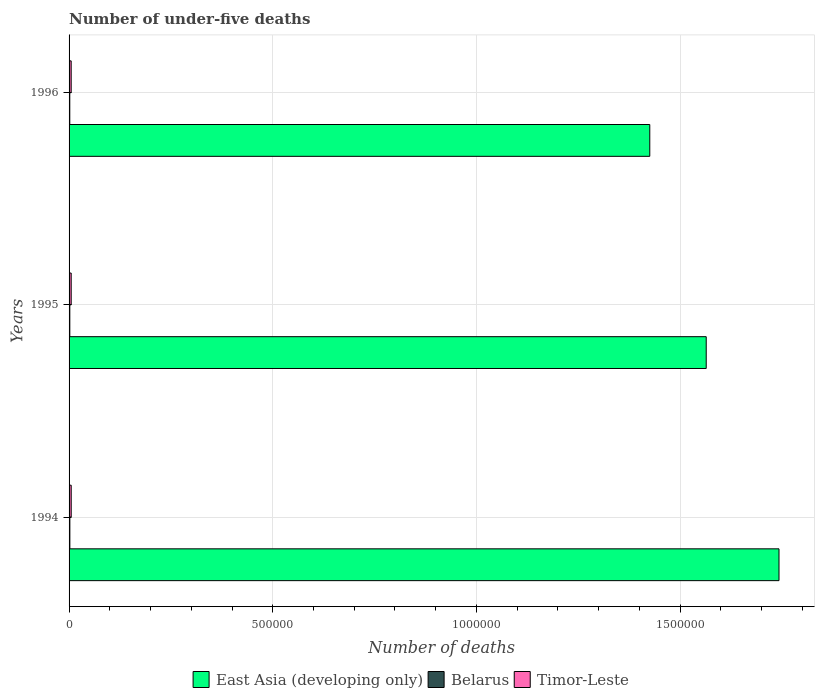Are the number of bars on each tick of the Y-axis equal?
Offer a terse response. Yes. How many bars are there on the 3rd tick from the bottom?
Make the answer very short. 3. What is the label of the 3rd group of bars from the top?
Provide a short and direct response. 1994. In how many cases, is the number of bars for a given year not equal to the number of legend labels?
Your answer should be very brief. 0. What is the number of under-five deaths in Timor-Leste in 1996?
Your answer should be compact. 5170. Across all years, what is the maximum number of under-five deaths in East Asia (developing only)?
Your answer should be very brief. 1.74e+06. Across all years, what is the minimum number of under-five deaths in Timor-Leste?
Your answer should be very brief. 5170. In which year was the number of under-five deaths in Timor-Leste maximum?
Your answer should be compact. 1994. In which year was the number of under-five deaths in Belarus minimum?
Offer a terse response. 1996. What is the total number of under-five deaths in East Asia (developing only) in the graph?
Give a very brief answer. 4.73e+06. What is the difference between the number of under-five deaths in Belarus in 1994 and the number of under-five deaths in Timor-Leste in 1995?
Provide a short and direct response. -3260. What is the average number of under-five deaths in Timor-Leste per year?
Provide a succinct answer. 5190.33. In the year 1994, what is the difference between the number of under-five deaths in Timor-Leste and number of under-five deaths in Belarus?
Your answer should be very brief. 3289. In how many years, is the number of under-five deaths in East Asia (developing only) greater than 100000 ?
Your response must be concise. 3. What is the ratio of the number of under-five deaths in Timor-Leste in 1994 to that in 1995?
Offer a very short reply. 1.01. What is the difference between the highest and the second highest number of under-five deaths in East Asia (developing only)?
Make the answer very short. 1.79e+05. In how many years, is the number of under-five deaths in East Asia (developing only) greater than the average number of under-five deaths in East Asia (developing only) taken over all years?
Offer a terse response. 1. What does the 1st bar from the top in 1995 represents?
Provide a short and direct response. Timor-Leste. What does the 3rd bar from the bottom in 1996 represents?
Provide a short and direct response. Timor-Leste. How many bars are there?
Offer a very short reply. 9. How many years are there in the graph?
Give a very brief answer. 3. Does the graph contain any zero values?
Provide a succinct answer. No. Does the graph contain grids?
Your answer should be compact. Yes. How are the legend labels stacked?
Your response must be concise. Horizontal. What is the title of the graph?
Your answer should be compact. Number of under-five deaths. What is the label or title of the X-axis?
Offer a terse response. Number of deaths. What is the label or title of the Y-axis?
Offer a terse response. Years. What is the Number of deaths of East Asia (developing only) in 1994?
Offer a terse response. 1.74e+06. What is the Number of deaths in Belarus in 1994?
Provide a succinct answer. 1926. What is the Number of deaths in Timor-Leste in 1994?
Your response must be concise. 5215. What is the Number of deaths of East Asia (developing only) in 1995?
Give a very brief answer. 1.56e+06. What is the Number of deaths of Belarus in 1995?
Offer a very short reply. 1832. What is the Number of deaths in Timor-Leste in 1995?
Provide a short and direct response. 5186. What is the Number of deaths in East Asia (developing only) in 1996?
Keep it short and to the point. 1.43e+06. What is the Number of deaths in Belarus in 1996?
Give a very brief answer. 1738. What is the Number of deaths in Timor-Leste in 1996?
Offer a very short reply. 5170. Across all years, what is the maximum Number of deaths of East Asia (developing only)?
Your answer should be very brief. 1.74e+06. Across all years, what is the maximum Number of deaths in Belarus?
Keep it short and to the point. 1926. Across all years, what is the maximum Number of deaths in Timor-Leste?
Your answer should be compact. 5215. Across all years, what is the minimum Number of deaths of East Asia (developing only)?
Provide a succinct answer. 1.43e+06. Across all years, what is the minimum Number of deaths in Belarus?
Offer a terse response. 1738. Across all years, what is the minimum Number of deaths of Timor-Leste?
Ensure brevity in your answer.  5170. What is the total Number of deaths in East Asia (developing only) in the graph?
Make the answer very short. 4.73e+06. What is the total Number of deaths in Belarus in the graph?
Make the answer very short. 5496. What is the total Number of deaths of Timor-Leste in the graph?
Offer a very short reply. 1.56e+04. What is the difference between the Number of deaths in East Asia (developing only) in 1994 and that in 1995?
Give a very brief answer. 1.79e+05. What is the difference between the Number of deaths of Belarus in 1994 and that in 1995?
Keep it short and to the point. 94. What is the difference between the Number of deaths in East Asia (developing only) in 1994 and that in 1996?
Offer a terse response. 3.17e+05. What is the difference between the Number of deaths of Belarus in 1994 and that in 1996?
Your response must be concise. 188. What is the difference between the Number of deaths in East Asia (developing only) in 1995 and that in 1996?
Your answer should be very brief. 1.39e+05. What is the difference between the Number of deaths in Belarus in 1995 and that in 1996?
Provide a succinct answer. 94. What is the difference between the Number of deaths of East Asia (developing only) in 1994 and the Number of deaths of Belarus in 1995?
Ensure brevity in your answer.  1.74e+06. What is the difference between the Number of deaths of East Asia (developing only) in 1994 and the Number of deaths of Timor-Leste in 1995?
Give a very brief answer. 1.74e+06. What is the difference between the Number of deaths in Belarus in 1994 and the Number of deaths in Timor-Leste in 1995?
Ensure brevity in your answer.  -3260. What is the difference between the Number of deaths of East Asia (developing only) in 1994 and the Number of deaths of Belarus in 1996?
Make the answer very short. 1.74e+06. What is the difference between the Number of deaths of East Asia (developing only) in 1994 and the Number of deaths of Timor-Leste in 1996?
Provide a short and direct response. 1.74e+06. What is the difference between the Number of deaths of Belarus in 1994 and the Number of deaths of Timor-Leste in 1996?
Make the answer very short. -3244. What is the difference between the Number of deaths of East Asia (developing only) in 1995 and the Number of deaths of Belarus in 1996?
Give a very brief answer. 1.56e+06. What is the difference between the Number of deaths in East Asia (developing only) in 1995 and the Number of deaths in Timor-Leste in 1996?
Give a very brief answer. 1.56e+06. What is the difference between the Number of deaths of Belarus in 1995 and the Number of deaths of Timor-Leste in 1996?
Give a very brief answer. -3338. What is the average Number of deaths of East Asia (developing only) per year?
Your response must be concise. 1.58e+06. What is the average Number of deaths in Belarus per year?
Provide a short and direct response. 1832. What is the average Number of deaths in Timor-Leste per year?
Make the answer very short. 5190.33. In the year 1994, what is the difference between the Number of deaths in East Asia (developing only) and Number of deaths in Belarus?
Offer a very short reply. 1.74e+06. In the year 1994, what is the difference between the Number of deaths in East Asia (developing only) and Number of deaths in Timor-Leste?
Provide a short and direct response. 1.74e+06. In the year 1994, what is the difference between the Number of deaths in Belarus and Number of deaths in Timor-Leste?
Provide a succinct answer. -3289. In the year 1995, what is the difference between the Number of deaths in East Asia (developing only) and Number of deaths in Belarus?
Provide a short and direct response. 1.56e+06. In the year 1995, what is the difference between the Number of deaths of East Asia (developing only) and Number of deaths of Timor-Leste?
Your response must be concise. 1.56e+06. In the year 1995, what is the difference between the Number of deaths of Belarus and Number of deaths of Timor-Leste?
Give a very brief answer. -3354. In the year 1996, what is the difference between the Number of deaths of East Asia (developing only) and Number of deaths of Belarus?
Provide a short and direct response. 1.42e+06. In the year 1996, what is the difference between the Number of deaths in East Asia (developing only) and Number of deaths in Timor-Leste?
Offer a very short reply. 1.42e+06. In the year 1996, what is the difference between the Number of deaths in Belarus and Number of deaths in Timor-Leste?
Offer a very short reply. -3432. What is the ratio of the Number of deaths in East Asia (developing only) in 1994 to that in 1995?
Give a very brief answer. 1.11. What is the ratio of the Number of deaths of Belarus in 1994 to that in 1995?
Offer a very short reply. 1.05. What is the ratio of the Number of deaths in Timor-Leste in 1994 to that in 1995?
Provide a short and direct response. 1.01. What is the ratio of the Number of deaths in East Asia (developing only) in 1994 to that in 1996?
Your answer should be compact. 1.22. What is the ratio of the Number of deaths of Belarus in 1994 to that in 1996?
Make the answer very short. 1.11. What is the ratio of the Number of deaths in Timor-Leste in 1994 to that in 1996?
Ensure brevity in your answer.  1.01. What is the ratio of the Number of deaths of East Asia (developing only) in 1995 to that in 1996?
Ensure brevity in your answer.  1.1. What is the ratio of the Number of deaths in Belarus in 1995 to that in 1996?
Offer a very short reply. 1.05. What is the ratio of the Number of deaths in Timor-Leste in 1995 to that in 1996?
Give a very brief answer. 1. What is the difference between the highest and the second highest Number of deaths in East Asia (developing only)?
Offer a very short reply. 1.79e+05. What is the difference between the highest and the second highest Number of deaths in Belarus?
Offer a very short reply. 94. What is the difference between the highest and the second highest Number of deaths in Timor-Leste?
Your answer should be compact. 29. What is the difference between the highest and the lowest Number of deaths in East Asia (developing only)?
Keep it short and to the point. 3.17e+05. What is the difference between the highest and the lowest Number of deaths of Belarus?
Keep it short and to the point. 188. 